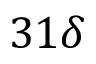<formula> <loc_0><loc_0><loc_500><loc_500>3 1 \delta</formula> 